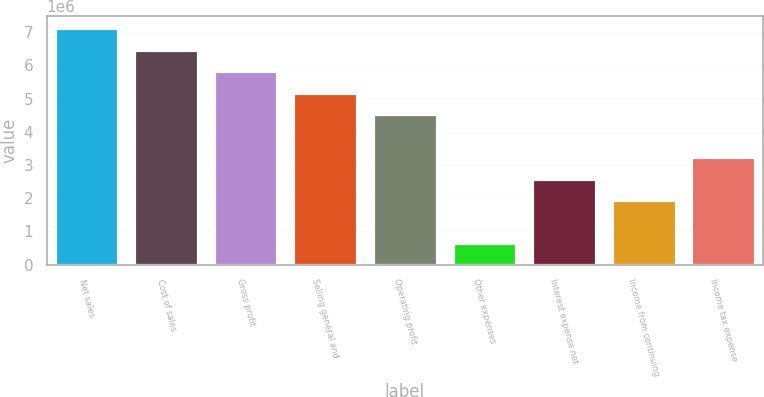Convert chart to OTSL. <chart><loc_0><loc_0><loc_500><loc_500><bar_chart><fcel>Net sales<fcel>Cost of sales<fcel>Gross profit<fcel>Selling general and<fcel>Operating profit<fcel>Other expenses<fcel>Interest expense net<fcel>Income from continuing<fcel>Income tax expense<nl><fcel>7.11855e+06<fcel>6.47141e+06<fcel>5.82427e+06<fcel>5.17713e+06<fcel>4.52999e+06<fcel>647141<fcel>2.58856e+06<fcel>1.94142e+06<fcel>3.23571e+06<nl></chart> 